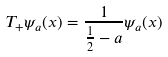<formula> <loc_0><loc_0><loc_500><loc_500>T _ { + } \psi _ { a } ( x ) = \frac { 1 } { \frac { 1 } { 2 } - a } \psi _ { a } ( x )</formula> 